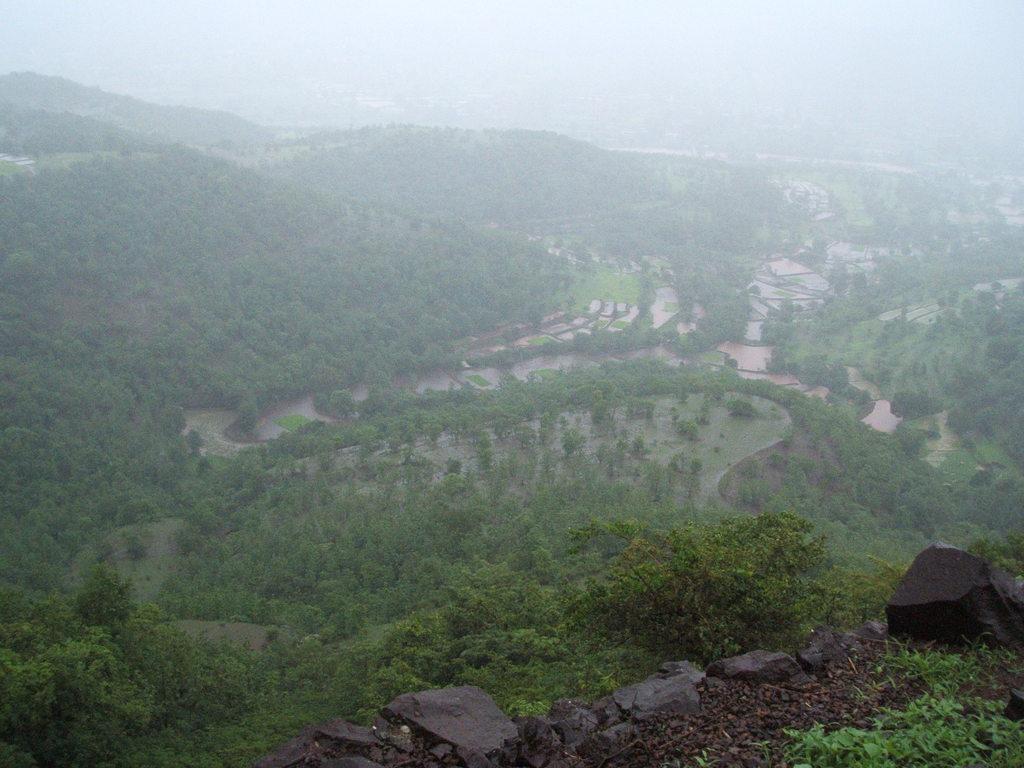How would you summarize this image in a sentence or two? In this image we can see few hills. There are many trees and plants in the image. There are few agricultural fields in the image There is a sky in the image. There few rocks in the image. 